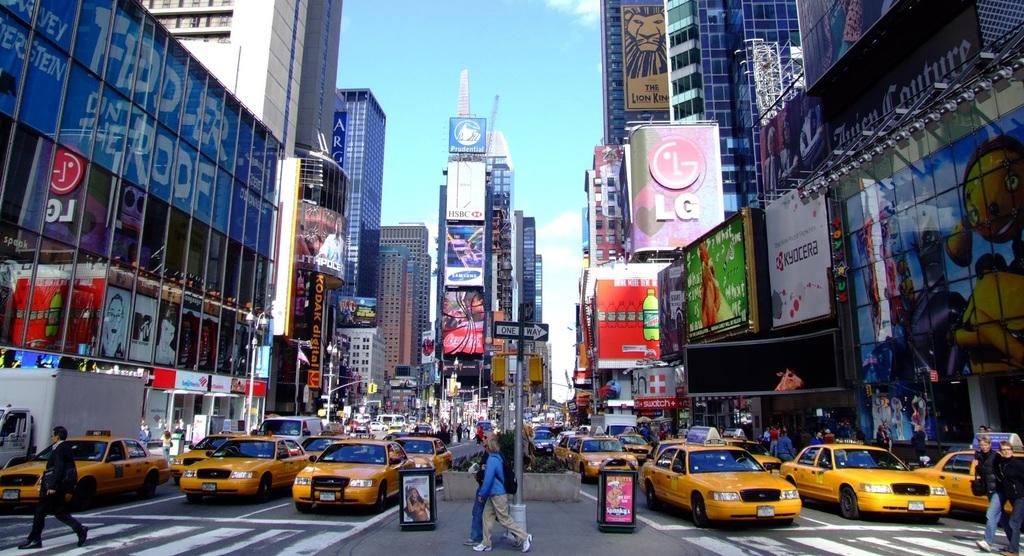What 2 letters are displayed on the sign under the circle type logo?
Give a very brief answer. Lg. 